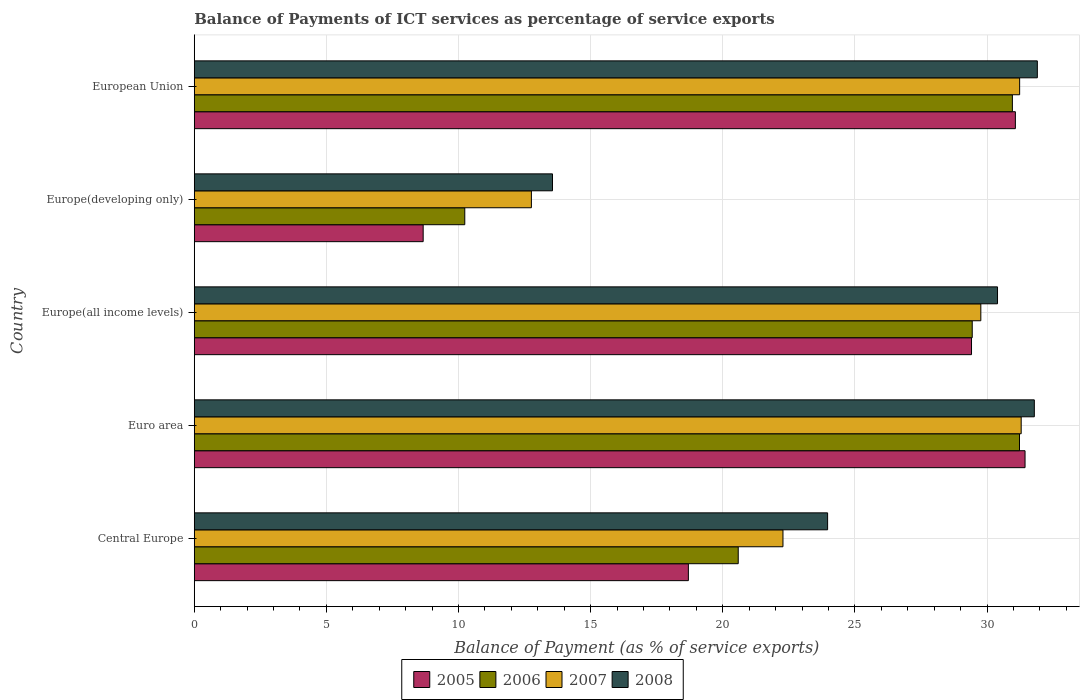How many bars are there on the 2nd tick from the top?
Your answer should be very brief. 4. How many bars are there on the 2nd tick from the bottom?
Provide a short and direct response. 4. What is the balance of payments of ICT services in 2005 in Europe(developing only)?
Provide a succinct answer. 8.66. Across all countries, what is the maximum balance of payments of ICT services in 2008?
Provide a succinct answer. 31.9. Across all countries, what is the minimum balance of payments of ICT services in 2008?
Give a very brief answer. 13.56. In which country was the balance of payments of ICT services in 2005 maximum?
Offer a terse response. Euro area. In which country was the balance of payments of ICT services in 2008 minimum?
Provide a short and direct response. Europe(developing only). What is the total balance of payments of ICT services in 2008 in the graph?
Your answer should be compact. 131.6. What is the difference between the balance of payments of ICT services in 2005 in Central Europe and that in Euro area?
Your answer should be very brief. -12.74. What is the difference between the balance of payments of ICT services in 2008 in Central Europe and the balance of payments of ICT services in 2006 in Europe(all income levels)?
Provide a short and direct response. -5.47. What is the average balance of payments of ICT services in 2006 per country?
Keep it short and to the point. 24.49. What is the difference between the balance of payments of ICT services in 2008 and balance of payments of ICT services in 2005 in Europe(all income levels)?
Provide a succinct answer. 0.98. In how many countries, is the balance of payments of ICT services in 2008 greater than 25 %?
Keep it short and to the point. 3. What is the ratio of the balance of payments of ICT services in 2006 in Euro area to that in Europe(all income levels)?
Offer a terse response. 1.06. Is the balance of payments of ICT services in 2007 in Central Europe less than that in Europe(all income levels)?
Your answer should be very brief. Yes. What is the difference between the highest and the second highest balance of payments of ICT services in 2008?
Your answer should be very brief. 0.11. What is the difference between the highest and the lowest balance of payments of ICT services in 2005?
Provide a succinct answer. 22.77. Is it the case that in every country, the sum of the balance of payments of ICT services in 2005 and balance of payments of ICT services in 2008 is greater than the sum of balance of payments of ICT services in 2006 and balance of payments of ICT services in 2007?
Ensure brevity in your answer.  No. What does the 4th bar from the bottom in Europe(developing only) represents?
Your answer should be very brief. 2008. Is it the case that in every country, the sum of the balance of payments of ICT services in 2007 and balance of payments of ICT services in 2005 is greater than the balance of payments of ICT services in 2008?
Ensure brevity in your answer.  Yes. How many bars are there?
Provide a succinct answer. 20. Are all the bars in the graph horizontal?
Offer a terse response. Yes. How many countries are there in the graph?
Your response must be concise. 5. Are the values on the major ticks of X-axis written in scientific E-notation?
Your response must be concise. No. Where does the legend appear in the graph?
Provide a short and direct response. Bottom center. How many legend labels are there?
Provide a short and direct response. 4. How are the legend labels stacked?
Keep it short and to the point. Horizontal. What is the title of the graph?
Keep it short and to the point. Balance of Payments of ICT services as percentage of service exports. Does "2007" appear as one of the legend labels in the graph?
Provide a short and direct response. Yes. What is the label or title of the X-axis?
Ensure brevity in your answer.  Balance of Payment (as % of service exports). What is the label or title of the Y-axis?
Provide a succinct answer. Country. What is the Balance of Payment (as % of service exports) in 2005 in Central Europe?
Make the answer very short. 18.7. What is the Balance of Payment (as % of service exports) of 2006 in Central Europe?
Keep it short and to the point. 20.58. What is the Balance of Payment (as % of service exports) of 2007 in Central Europe?
Give a very brief answer. 22.28. What is the Balance of Payment (as % of service exports) in 2008 in Central Europe?
Offer a very short reply. 23.97. What is the Balance of Payment (as % of service exports) in 2005 in Euro area?
Make the answer very short. 31.44. What is the Balance of Payment (as % of service exports) of 2006 in Euro area?
Offer a very short reply. 31.23. What is the Balance of Payment (as % of service exports) of 2007 in Euro area?
Offer a very short reply. 31.29. What is the Balance of Payment (as % of service exports) of 2008 in Euro area?
Ensure brevity in your answer.  31.79. What is the Balance of Payment (as % of service exports) in 2005 in Europe(all income levels)?
Keep it short and to the point. 29.41. What is the Balance of Payment (as % of service exports) in 2006 in Europe(all income levels)?
Your answer should be compact. 29.44. What is the Balance of Payment (as % of service exports) of 2007 in Europe(all income levels)?
Keep it short and to the point. 29.76. What is the Balance of Payment (as % of service exports) of 2008 in Europe(all income levels)?
Make the answer very short. 30.39. What is the Balance of Payment (as % of service exports) of 2005 in Europe(developing only)?
Make the answer very short. 8.66. What is the Balance of Payment (as % of service exports) of 2006 in Europe(developing only)?
Provide a succinct answer. 10.24. What is the Balance of Payment (as % of service exports) in 2007 in Europe(developing only)?
Your answer should be very brief. 12.76. What is the Balance of Payment (as % of service exports) in 2008 in Europe(developing only)?
Ensure brevity in your answer.  13.56. What is the Balance of Payment (as % of service exports) of 2005 in European Union?
Your answer should be compact. 31.07. What is the Balance of Payment (as % of service exports) of 2006 in European Union?
Offer a terse response. 30.96. What is the Balance of Payment (as % of service exports) of 2007 in European Union?
Ensure brevity in your answer.  31.23. What is the Balance of Payment (as % of service exports) in 2008 in European Union?
Offer a very short reply. 31.9. Across all countries, what is the maximum Balance of Payment (as % of service exports) of 2005?
Your response must be concise. 31.44. Across all countries, what is the maximum Balance of Payment (as % of service exports) in 2006?
Provide a short and direct response. 31.23. Across all countries, what is the maximum Balance of Payment (as % of service exports) in 2007?
Provide a succinct answer. 31.29. Across all countries, what is the maximum Balance of Payment (as % of service exports) in 2008?
Keep it short and to the point. 31.9. Across all countries, what is the minimum Balance of Payment (as % of service exports) in 2005?
Give a very brief answer. 8.66. Across all countries, what is the minimum Balance of Payment (as % of service exports) in 2006?
Keep it short and to the point. 10.24. Across all countries, what is the minimum Balance of Payment (as % of service exports) of 2007?
Your response must be concise. 12.76. Across all countries, what is the minimum Balance of Payment (as % of service exports) in 2008?
Your response must be concise. 13.56. What is the total Balance of Payment (as % of service exports) of 2005 in the graph?
Provide a short and direct response. 119.27. What is the total Balance of Payment (as % of service exports) of 2006 in the graph?
Provide a succinct answer. 122.44. What is the total Balance of Payment (as % of service exports) of 2007 in the graph?
Your response must be concise. 127.32. What is the total Balance of Payment (as % of service exports) of 2008 in the graph?
Offer a terse response. 131.6. What is the difference between the Balance of Payment (as % of service exports) of 2005 in Central Europe and that in Euro area?
Your response must be concise. -12.74. What is the difference between the Balance of Payment (as % of service exports) in 2006 in Central Europe and that in Euro area?
Offer a terse response. -10.64. What is the difference between the Balance of Payment (as % of service exports) of 2007 in Central Europe and that in Euro area?
Your answer should be compact. -9.01. What is the difference between the Balance of Payment (as % of service exports) in 2008 in Central Europe and that in Euro area?
Offer a very short reply. -7.82. What is the difference between the Balance of Payment (as % of service exports) of 2005 in Central Europe and that in Europe(all income levels)?
Make the answer very short. -10.71. What is the difference between the Balance of Payment (as % of service exports) of 2006 in Central Europe and that in Europe(all income levels)?
Make the answer very short. -8.85. What is the difference between the Balance of Payment (as % of service exports) in 2007 in Central Europe and that in Europe(all income levels)?
Ensure brevity in your answer.  -7.49. What is the difference between the Balance of Payment (as % of service exports) in 2008 in Central Europe and that in Europe(all income levels)?
Provide a succinct answer. -6.43. What is the difference between the Balance of Payment (as % of service exports) of 2005 in Central Europe and that in Europe(developing only)?
Give a very brief answer. 10.04. What is the difference between the Balance of Payment (as % of service exports) of 2006 in Central Europe and that in Europe(developing only)?
Offer a terse response. 10.35. What is the difference between the Balance of Payment (as % of service exports) in 2007 in Central Europe and that in Europe(developing only)?
Offer a very short reply. 9.52. What is the difference between the Balance of Payment (as % of service exports) of 2008 in Central Europe and that in Europe(developing only)?
Ensure brevity in your answer.  10.41. What is the difference between the Balance of Payment (as % of service exports) in 2005 in Central Europe and that in European Union?
Make the answer very short. -12.37. What is the difference between the Balance of Payment (as % of service exports) in 2006 in Central Europe and that in European Union?
Offer a very short reply. -10.37. What is the difference between the Balance of Payment (as % of service exports) of 2007 in Central Europe and that in European Union?
Your response must be concise. -8.96. What is the difference between the Balance of Payment (as % of service exports) of 2008 in Central Europe and that in European Union?
Provide a succinct answer. -7.94. What is the difference between the Balance of Payment (as % of service exports) in 2005 in Euro area and that in Europe(all income levels)?
Ensure brevity in your answer.  2.03. What is the difference between the Balance of Payment (as % of service exports) in 2006 in Euro area and that in Europe(all income levels)?
Keep it short and to the point. 1.79. What is the difference between the Balance of Payment (as % of service exports) of 2007 in Euro area and that in Europe(all income levels)?
Make the answer very short. 1.53. What is the difference between the Balance of Payment (as % of service exports) in 2008 in Euro area and that in Europe(all income levels)?
Make the answer very short. 1.39. What is the difference between the Balance of Payment (as % of service exports) of 2005 in Euro area and that in Europe(developing only)?
Keep it short and to the point. 22.77. What is the difference between the Balance of Payment (as % of service exports) of 2006 in Euro area and that in Europe(developing only)?
Give a very brief answer. 20.99. What is the difference between the Balance of Payment (as % of service exports) in 2007 in Euro area and that in Europe(developing only)?
Ensure brevity in your answer.  18.53. What is the difference between the Balance of Payment (as % of service exports) in 2008 in Euro area and that in Europe(developing only)?
Provide a succinct answer. 18.23. What is the difference between the Balance of Payment (as % of service exports) in 2005 in Euro area and that in European Union?
Your response must be concise. 0.37. What is the difference between the Balance of Payment (as % of service exports) of 2006 in Euro area and that in European Union?
Offer a very short reply. 0.27. What is the difference between the Balance of Payment (as % of service exports) in 2007 in Euro area and that in European Union?
Offer a very short reply. 0.06. What is the difference between the Balance of Payment (as % of service exports) of 2008 in Euro area and that in European Union?
Make the answer very short. -0.11. What is the difference between the Balance of Payment (as % of service exports) of 2005 in Europe(all income levels) and that in Europe(developing only)?
Make the answer very short. 20.75. What is the difference between the Balance of Payment (as % of service exports) of 2006 in Europe(all income levels) and that in Europe(developing only)?
Offer a terse response. 19.2. What is the difference between the Balance of Payment (as % of service exports) in 2007 in Europe(all income levels) and that in Europe(developing only)?
Ensure brevity in your answer.  17.01. What is the difference between the Balance of Payment (as % of service exports) in 2008 in Europe(all income levels) and that in Europe(developing only)?
Your answer should be compact. 16.84. What is the difference between the Balance of Payment (as % of service exports) of 2005 in Europe(all income levels) and that in European Union?
Make the answer very short. -1.66. What is the difference between the Balance of Payment (as % of service exports) in 2006 in Europe(all income levels) and that in European Union?
Keep it short and to the point. -1.52. What is the difference between the Balance of Payment (as % of service exports) of 2007 in Europe(all income levels) and that in European Union?
Provide a succinct answer. -1.47. What is the difference between the Balance of Payment (as % of service exports) of 2008 in Europe(all income levels) and that in European Union?
Provide a short and direct response. -1.51. What is the difference between the Balance of Payment (as % of service exports) in 2005 in Europe(developing only) and that in European Union?
Your answer should be very brief. -22.41. What is the difference between the Balance of Payment (as % of service exports) of 2006 in Europe(developing only) and that in European Union?
Provide a short and direct response. -20.72. What is the difference between the Balance of Payment (as % of service exports) in 2007 in Europe(developing only) and that in European Union?
Offer a terse response. -18.47. What is the difference between the Balance of Payment (as % of service exports) in 2008 in Europe(developing only) and that in European Union?
Make the answer very short. -18.35. What is the difference between the Balance of Payment (as % of service exports) in 2005 in Central Europe and the Balance of Payment (as % of service exports) in 2006 in Euro area?
Your answer should be compact. -12.53. What is the difference between the Balance of Payment (as % of service exports) of 2005 in Central Europe and the Balance of Payment (as % of service exports) of 2007 in Euro area?
Offer a terse response. -12.59. What is the difference between the Balance of Payment (as % of service exports) in 2005 in Central Europe and the Balance of Payment (as % of service exports) in 2008 in Euro area?
Your answer should be compact. -13.09. What is the difference between the Balance of Payment (as % of service exports) in 2006 in Central Europe and the Balance of Payment (as % of service exports) in 2007 in Euro area?
Keep it short and to the point. -10.71. What is the difference between the Balance of Payment (as % of service exports) of 2006 in Central Europe and the Balance of Payment (as % of service exports) of 2008 in Euro area?
Your answer should be very brief. -11.2. What is the difference between the Balance of Payment (as % of service exports) in 2007 in Central Europe and the Balance of Payment (as % of service exports) in 2008 in Euro area?
Provide a short and direct response. -9.51. What is the difference between the Balance of Payment (as % of service exports) in 2005 in Central Europe and the Balance of Payment (as % of service exports) in 2006 in Europe(all income levels)?
Make the answer very short. -10.74. What is the difference between the Balance of Payment (as % of service exports) of 2005 in Central Europe and the Balance of Payment (as % of service exports) of 2007 in Europe(all income levels)?
Your response must be concise. -11.07. What is the difference between the Balance of Payment (as % of service exports) of 2005 in Central Europe and the Balance of Payment (as % of service exports) of 2008 in Europe(all income levels)?
Ensure brevity in your answer.  -11.7. What is the difference between the Balance of Payment (as % of service exports) of 2006 in Central Europe and the Balance of Payment (as % of service exports) of 2007 in Europe(all income levels)?
Provide a short and direct response. -9.18. What is the difference between the Balance of Payment (as % of service exports) in 2006 in Central Europe and the Balance of Payment (as % of service exports) in 2008 in Europe(all income levels)?
Give a very brief answer. -9.81. What is the difference between the Balance of Payment (as % of service exports) of 2007 in Central Europe and the Balance of Payment (as % of service exports) of 2008 in Europe(all income levels)?
Your response must be concise. -8.12. What is the difference between the Balance of Payment (as % of service exports) of 2005 in Central Europe and the Balance of Payment (as % of service exports) of 2006 in Europe(developing only)?
Provide a succinct answer. 8.46. What is the difference between the Balance of Payment (as % of service exports) of 2005 in Central Europe and the Balance of Payment (as % of service exports) of 2007 in Europe(developing only)?
Provide a succinct answer. 5.94. What is the difference between the Balance of Payment (as % of service exports) in 2005 in Central Europe and the Balance of Payment (as % of service exports) in 2008 in Europe(developing only)?
Your answer should be compact. 5.14. What is the difference between the Balance of Payment (as % of service exports) of 2006 in Central Europe and the Balance of Payment (as % of service exports) of 2007 in Europe(developing only)?
Ensure brevity in your answer.  7.83. What is the difference between the Balance of Payment (as % of service exports) of 2006 in Central Europe and the Balance of Payment (as % of service exports) of 2008 in Europe(developing only)?
Provide a short and direct response. 7.03. What is the difference between the Balance of Payment (as % of service exports) of 2007 in Central Europe and the Balance of Payment (as % of service exports) of 2008 in Europe(developing only)?
Make the answer very short. 8.72. What is the difference between the Balance of Payment (as % of service exports) of 2005 in Central Europe and the Balance of Payment (as % of service exports) of 2006 in European Union?
Give a very brief answer. -12.26. What is the difference between the Balance of Payment (as % of service exports) in 2005 in Central Europe and the Balance of Payment (as % of service exports) in 2007 in European Union?
Provide a succinct answer. -12.54. What is the difference between the Balance of Payment (as % of service exports) in 2005 in Central Europe and the Balance of Payment (as % of service exports) in 2008 in European Union?
Your answer should be compact. -13.2. What is the difference between the Balance of Payment (as % of service exports) in 2006 in Central Europe and the Balance of Payment (as % of service exports) in 2007 in European Union?
Make the answer very short. -10.65. What is the difference between the Balance of Payment (as % of service exports) of 2006 in Central Europe and the Balance of Payment (as % of service exports) of 2008 in European Union?
Offer a terse response. -11.32. What is the difference between the Balance of Payment (as % of service exports) of 2007 in Central Europe and the Balance of Payment (as % of service exports) of 2008 in European Union?
Provide a short and direct response. -9.62. What is the difference between the Balance of Payment (as % of service exports) in 2005 in Euro area and the Balance of Payment (as % of service exports) in 2006 in Europe(all income levels)?
Keep it short and to the point. 2. What is the difference between the Balance of Payment (as % of service exports) of 2005 in Euro area and the Balance of Payment (as % of service exports) of 2007 in Europe(all income levels)?
Make the answer very short. 1.67. What is the difference between the Balance of Payment (as % of service exports) in 2005 in Euro area and the Balance of Payment (as % of service exports) in 2008 in Europe(all income levels)?
Give a very brief answer. 1.04. What is the difference between the Balance of Payment (as % of service exports) in 2006 in Euro area and the Balance of Payment (as % of service exports) in 2007 in Europe(all income levels)?
Your answer should be compact. 1.46. What is the difference between the Balance of Payment (as % of service exports) in 2006 in Euro area and the Balance of Payment (as % of service exports) in 2008 in Europe(all income levels)?
Provide a succinct answer. 0.83. What is the difference between the Balance of Payment (as % of service exports) of 2007 in Euro area and the Balance of Payment (as % of service exports) of 2008 in Europe(all income levels)?
Keep it short and to the point. 0.9. What is the difference between the Balance of Payment (as % of service exports) in 2005 in Euro area and the Balance of Payment (as % of service exports) in 2006 in Europe(developing only)?
Offer a terse response. 21.2. What is the difference between the Balance of Payment (as % of service exports) of 2005 in Euro area and the Balance of Payment (as % of service exports) of 2007 in Europe(developing only)?
Offer a terse response. 18.68. What is the difference between the Balance of Payment (as % of service exports) of 2005 in Euro area and the Balance of Payment (as % of service exports) of 2008 in Europe(developing only)?
Your answer should be very brief. 17.88. What is the difference between the Balance of Payment (as % of service exports) of 2006 in Euro area and the Balance of Payment (as % of service exports) of 2007 in Europe(developing only)?
Offer a terse response. 18.47. What is the difference between the Balance of Payment (as % of service exports) of 2006 in Euro area and the Balance of Payment (as % of service exports) of 2008 in Europe(developing only)?
Your answer should be compact. 17.67. What is the difference between the Balance of Payment (as % of service exports) of 2007 in Euro area and the Balance of Payment (as % of service exports) of 2008 in Europe(developing only)?
Make the answer very short. 17.73. What is the difference between the Balance of Payment (as % of service exports) of 2005 in Euro area and the Balance of Payment (as % of service exports) of 2006 in European Union?
Offer a terse response. 0.48. What is the difference between the Balance of Payment (as % of service exports) of 2005 in Euro area and the Balance of Payment (as % of service exports) of 2007 in European Union?
Offer a very short reply. 0.2. What is the difference between the Balance of Payment (as % of service exports) of 2005 in Euro area and the Balance of Payment (as % of service exports) of 2008 in European Union?
Give a very brief answer. -0.47. What is the difference between the Balance of Payment (as % of service exports) of 2006 in Euro area and the Balance of Payment (as % of service exports) of 2007 in European Union?
Offer a very short reply. -0.01. What is the difference between the Balance of Payment (as % of service exports) of 2006 in Euro area and the Balance of Payment (as % of service exports) of 2008 in European Union?
Give a very brief answer. -0.68. What is the difference between the Balance of Payment (as % of service exports) in 2007 in Euro area and the Balance of Payment (as % of service exports) in 2008 in European Union?
Ensure brevity in your answer.  -0.61. What is the difference between the Balance of Payment (as % of service exports) of 2005 in Europe(all income levels) and the Balance of Payment (as % of service exports) of 2006 in Europe(developing only)?
Offer a terse response. 19.17. What is the difference between the Balance of Payment (as % of service exports) in 2005 in Europe(all income levels) and the Balance of Payment (as % of service exports) in 2007 in Europe(developing only)?
Give a very brief answer. 16.65. What is the difference between the Balance of Payment (as % of service exports) in 2005 in Europe(all income levels) and the Balance of Payment (as % of service exports) in 2008 in Europe(developing only)?
Your answer should be compact. 15.86. What is the difference between the Balance of Payment (as % of service exports) of 2006 in Europe(all income levels) and the Balance of Payment (as % of service exports) of 2007 in Europe(developing only)?
Offer a very short reply. 16.68. What is the difference between the Balance of Payment (as % of service exports) in 2006 in Europe(all income levels) and the Balance of Payment (as % of service exports) in 2008 in Europe(developing only)?
Provide a short and direct response. 15.88. What is the difference between the Balance of Payment (as % of service exports) of 2007 in Europe(all income levels) and the Balance of Payment (as % of service exports) of 2008 in Europe(developing only)?
Your answer should be very brief. 16.21. What is the difference between the Balance of Payment (as % of service exports) in 2005 in Europe(all income levels) and the Balance of Payment (as % of service exports) in 2006 in European Union?
Your answer should be very brief. -1.55. What is the difference between the Balance of Payment (as % of service exports) of 2005 in Europe(all income levels) and the Balance of Payment (as % of service exports) of 2007 in European Union?
Make the answer very short. -1.82. What is the difference between the Balance of Payment (as % of service exports) of 2005 in Europe(all income levels) and the Balance of Payment (as % of service exports) of 2008 in European Union?
Your answer should be compact. -2.49. What is the difference between the Balance of Payment (as % of service exports) of 2006 in Europe(all income levels) and the Balance of Payment (as % of service exports) of 2007 in European Union?
Offer a very short reply. -1.79. What is the difference between the Balance of Payment (as % of service exports) in 2006 in Europe(all income levels) and the Balance of Payment (as % of service exports) in 2008 in European Union?
Ensure brevity in your answer.  -2.46. What is the difference between the Balance of Payment (as % of service exports) of 2007 in Europe(all income levels) and the Balance of Payment (as % of service exports) of 2008 in European Union?
Make the answer very short. -2.14. What is the difference between the Balance of Payment (as % of service exports) of 2005 in Europe(developing only) and the Balance of Payment (as % of service exports) of 2006 in European Union?
Offer a very short reply. -22.3. What is the difference between the Balance of Payment (as % of service exports) of 2005 in Europe(developing only) and the Balance of Payment (as % of service exports) of 2007 in European Union?
Your response must be concise. -22.57. What is the difference between the Balance of Payment (as % of service exports) of 2005 in Europe(developing only) and the Balance of Payment (as % of service exports) of 2008 in European Union?
Offer a terse response. -23.24. What is the difference between the Balance of Payment (as % of service exports) in 2006 in Europe(developing only) and the Balance of Payment (as % of service exports) in 2007 in European Union?
Offer a terse response. -21. What is the difference between the Balance of Payment (as % of service exports) of 2006 in Europe(developing only) and the Balance of Payment (as % of service exports) of 2008 in European Union?
Your response must be concise. -21.66. What is the difference between the Balance of Payment (as % of service exports) in 2007 in Europe(developing only) and the Balance of Payment (as % of service exports) in 2008 in European Union?
Provide a succinct answer. -19.14. What is the average Balance of Payment (as % of service exports) in 2005 per country?
Make the answer very short. 23.85. What is the average Balance of Payment (as % of service exports) in 2006 per country?
Ensure brevity in your answer.  24.49. What is the average Balance of Payment (as % of service exports) of 2007 per country?
Keep it short and to the point. 25.46. What is the average Balance of Payment (as % of service exports) of 2008 per country?
Provide a succinct answer. 26.32. What is the difference between the Balance of Payment (as % of service exports) in 2005 and Balance of Payment (as % of service exports) in 2006 in Central Europe?
Your answer should be compact. -1.89. What is the difference between the Balance of Payment (as % of service exports) in 2005 and Balance of Payment (as % of service exports) in 2007 in Central Europe?
Your answer should be very brief. -3.58. What is the difference between the Balance of Payment (as % of service exports) in 2005 and Balance of Payment (as % of service exports) in 2008 in Central Europe?
Provide a succinct answer. -5.27. What is the difference between the Balance of Payment (as % of service exports) of 2006 and Balance of Payment (as % of service exports) of 2007 in Central Europe?
Provide a succinct answer. -1.69. What is the difference between the Balance of Payment (as % of service exports) in 2006 and Balance of Payment (as % of service exports) in 2008 in Central Europe?
Ensure brevity in your answer.  -3.38. What is the difference between the Balance of Payment (as % of service exports) in 2007 and Balance of Payment (as % of service exports) in 2008 in Central Europe?
Provide a succinct answer. -1.69. What is the difference between the Balance of Payment (as % of service exports) in 2005 and Balance of Payment (as % of service exports) in 2006 in Euro area?
Provide a succinct answer. 0.21. What is the difference between the Balance of Payment (as % of service exports) in 2005 and Balance of Payment (as % of service exports) in 2007 in Euro area?
Provide a short and direct response. 0.15. What is the difference between the Balance of Payment (as % of service exports) of 2005 and Balance of Payment (as % of service exports) of 2008 in Euro area?
Provide a succinct answer. -0.35. What is the difference between the Balance of Payment (as % of service exports) of 2006 and Balance of Payment (as % of service exports) of 2007 in Euro area?
Provide a short and direct response. -0.06. What is the difference between the Balance of Payment (as % of service exports) of 2006 and Balance of Payment (as % of service exports) of 2008 in Euro area?
Your answer should be compact. -0.56. What is the difference between the Balance of Payment (as % of service exports) of 2007 and Balance of Payment (as % of service exports) of 2008 in Euro area?
Ensure brevity in your answer.  -0.5. What is the difference between the Balance of Payment (as % of service exports) of 2005 and Balance of Payment (as % of service exports) of 2006 in Europe(all income levels)?
Offer a very short reply. -0.03. What is the difference between the Balance of Payment (as % of service exports) in 2005 and Balance of Payment (as % of service exports) in 2007 in Europe(all income levels)?
Offer a terse response. -0.35. What is the difference between the Balance of Payment (as % of service exports) of 2005 and Balance of Payment (as % of service exports) of 2008 in Europe(all income levels)?
Provide a short and direct response. -0.98. What is the difference between the Balance of Payment (as % of service exports) in 2006 and Balance of Payment (as % of service exports) in 2007 in Europe(all income levels)?
Make the answer very short. -0.33. What is the difference between the Balance of Payment (as % of service exports) of 2006 and Balance of Payment (as % of service exports) of 2008 in Europe(all income levels)?
Make the answer very short. -0.96. What is the difference between the Balance of Payment (as % of service exports) in 2007 and Balance of Payment (as % of service exports) in 2008 in Europe(all income levels)?
Offer a very short reply. -0.63. What is the difference between the Balance of Payment (as % of service exports) of 2005 and Balance of Payment (as % of service exports) of 2006 in Europe(developing only)?
Offer a very short reply. -1.57. What is the difference between the Balance of Payment (as % of service exports) of 2005 and Balance of Payment (as % of service exports) of 2007 in Europe(developing only)?
Make the answer very short. -4.1. What is the difference between the Balance of Payment (as % of service exports) of 2005 and Balance of Payment (as % of service exports) of 2008 in Europe(developing only)?
Offer a terse response. -4.89. What is the difference between the Balance of Payment (as % of service exports) in 2006 and Balance of Payment (as % of service exports) in 2007 in Europe(developing only)?
Make the answer very short. -2.52. What is the difference between the Balance of Payment (as % of service exports) in 2006 and Balance of Payment (as % of service exports) in 2008 in Europe(developing only)?
Provide a short and direct response. -3.32. What is the difference between the Balance of Payment (as % of service exports) of 2007 and Balance of Payment (as % of service exports) of 2008 in Europe(developing only)?
Offer a terse response. -0.8. What is the difference between the Balance of Payment (as % of service exports) in 2005 and Balance of Payment (as % of service exports) in 2006 in European Union?
Make the answer very short. 0.11. What is the difference between the Balance of Payment (as % of service exports) of 2005 and Balance of Payment (as % of service exports) of 2007 in European Union?
Give a very brief answer. -0.16. What is the difference between the Balance of Payment (as % of service exports) in 2005 and Balance of Payment (as % of service exports) in 2008 in European Union?
Give a very brief answer. -0.83. What is the difference between the Balance of Payment (as % of service exports) in 2006 and Balance of Payment (as % of service exports) in 2007 in European Union?
Your answer should be compact. -0.27. What is the difference between the Balance of Payment (as % of service exports) in 2006 and Balance of Payment (as % of service exports) in 2008 in European Union?
Give a very brief answer. -0.94. What is the difference between the Balance of Payment (as % of service exports) of 2007 and Balance of Payment (as % of service exports) of 2008 in European Union?
Your answer should be compact. -0.67. What is the ratio of the Balance of Payment (as % of service exports) of 2005 in Central Europe to that in Euro area?
Make the answer very short. 0.59. What is the ratio of the Balance of Payment (as % of service exports) of 2006 in Central Europe to that in Euro area?
Provide a short and direct response. 0.66. What is the ratio of the Balance of Payment (as % of service exports) of 2007 in Central Europe to that in Euro area?
Ensure brevity in your answer.  0.71. What is the ratio of the Balance of Payment (as % of service exports) of 2008 in Central Europe to that in Euro area?
Keep it short and to the point. 0.75. What is the ratio of the Balance of Payment (as % of service exports) of 2005 in Central Europe to that in Europe(all income levels)?
Give a very brief answer. 0.64. What is the ratio of the Balance of Payment (as % of service exports) of 2006 in Central Europe to that in Europe(all income levels)?
Your response must be concise. 0.7. What is the ratio of the Balance of Payment (as % of service exports) of 2007 in Central Europe to that in Europe(all income levels)?
Your response must be concise. 0.75. What is the ratio of the Balance of Payment (as % of service exports) in 2008 in Central Europe to that in Europe(all income levels)?
Provide a short and direct response. 0.79. What is the ratio of the Balance of Payment (as % of service exports) in 2005 in Central Europe to that in Europe(developing only)?
Ensure brevity in your answer.  2.16. What is the ratio of the Balance of Payment (as % of service exports) of 2006 in Central Europe to that in Europe(developing only)?
Make the answer very short. 2.01. What is the ratio of the Balance of Payment (as % of service exports) in 2007 in Central Europe to that in Europe(developing only)?
Ensure brevity in your answer.  1.75. What is the ratio of the Balance of Payment (as % of service exports) in 2008 in Central Europe to that in Europe(developing only)?
Your response must be concise. 1.77. What is the ratio of the Balance of Payment (as % of service exports) in 2005 in Central Europe to that in European Union?
Your answer should be very brief. 0.6. What is the ratio of the Balance of Payment (as % of service exports) in 2006 in Central Europe to that in European Union?
Ensure brevity in your answer.  0.66. What is the ratio of the Balance of Payment (as % of service exports) of 2007 in Central Europe to that in European Union?
Provide a succinct answer. 0.71. What is the ratio of the Balance of Payment (as % of service exports) of 2008 in Central Europe to that in European Union?
Keep it short and to the point. 0.75. What is the ratio of the Balance of Payment (as % of service exports) of 2005 in Euro area to that in Europe(all income levels)?
Provide a short and direct response. 1.07. What is the ratio of the Balance of Payment (as % of service exports) of 2006 in Euro area to that in Europe(all income levels)?
Offer a terse response. 1.06. What is the ratio of the Balance of Payment (as % of service exports) in 2007 in Euro area to that in Europe(all income levels)?
Offer a very short reply. 1.05. What is the ratio of the Balance of Payment (as % of service exports) in 2008 in Euro area to that in Europe(all income levels)?
Provide a succinct answer. 1.05. What is the ratio of the Balance of Payment (as % of service exports) of 2005 in Euro area to that in Europe(developing only)?
Provide a short and direct response. 3.63. What is the ratio of the Balance of Payment (as % of service exports) of 2006 in Euro area to that in Europe(developing only)?
Give a very brief answer. 3.05. What is the ratio of the Balance of Payment (as % of service exports) in 2007 in Euro area to that in Europe(developing only)?
Offer a very short reply. 2.45. What is the ratio of the Balance of Payment (as % of service exports) of 2008 in Euro area to that in Europe(developing only)?
Provide a short and direct response. 2.35. What is the ratio of the Balance of Payment (as % of service exports) of 2005 in Euro area to that in European Union?
Give a very brief answer. 1.01. What is the ratio of the Balance of Payment (as % of service exports) of 2006 in Euro area to that in European Union?
Your answer should be very brief. 1.01. What is the ratio of the Balance of Payment (as % of service exports) in 2007 in Euro area to that in European Union?
Give a very brief answer. 1. What is the ratio of the Balance of Payment (as % of service exports) in 2005 in Europe(all income levels) to that in Europe(developing only)?
Provide a short and direct response. 3.4. What is the ratio of the Balance of Payment (as % of service exports) in 2006 in Europe(all income levels) to that in Europe(developing only)?
Offer a very short reply. 2.88. What is the ratio of the Balance of Payment (as % of service exports) of 2007 in Europe(all income levels) to that in Europe(developing only)?
Your answer should be compact. 2.33. What is the ratio of the Balance of Payment (as % of service exports) of 2008 in Europe(all income levels) to that in Europe(developing only)?
Your response must be concise. 2.24. What is the ratio of the Balance of Payment (as % of service exports) of 2005 in Europe(all income levels) to that in European Union?
Provide a short and direct response. 0.95. What is the ratio of the Balance of Payment (as % of service exports) in 2006 in Europe(all income levels) to that in European Union?
Provide a succinct answer. 0.95. What is the ratio of the Balance of Payment (as % of service exports) in 2007 in Europe(all income levels) to that in European Union?
Your answer should be compact. 0.95. What is the ratio of the Balance of Payment (as % of service exports) in 2008 in Europe(all income levels) to that in European Union?
Keep it short and to the point. 0.95. What is the ratio of the Balance of Payment (as % of service exports) in 2005 in Europe(developing only) to that in European Union?
Provide a succinct answer. 0.28. What is the ratio of the Balance of Payment (as % of service exports) in 2006 in Europe(developing only) to that in European Union?
Offer a terse response. 0.33. What is the ratio of the Balance of Payment (as % of service exports) in 2007 in Europe(developing only) to that in European Union?
Keep it short and to the point. 0.41. What is the ratio of the Balance of Payment (as % of service exports) in 2008 in Europe(developing only) to that in European Union?
Ensure brevity in your answer.  0.42. What is the difference between the highest and the second highest Balance of Payment (as % of service exports) of 2005?
Offer a very short reply. 0.37. What is the difference between the highest and the second highest Balance of Payment (as % of service exports) of 2006?
Your answer should be compact. 0.27. What is the difference between the highest and the second highest Balance of Payment (as % of service exports) of 2007?
Provide a short and direct response. 0.06. What is the difference between the highest and the second highest Balance of Payment (as % of service exports) in 2008?
Give a very brief answer. 0.11. What is the difference between the highest and the lowest Balance of Payment (as % of service exports) in 2005?
Provide a succinct answer. 22.77. What is the difference between the highest and the lowest Balance of Payment (as % of service exports) in 2006?
Offer a terse response. 20.99. What is the difference between the highest and the lowest Balance of Payment (as % of service exports) in 2007?
Make the answer very short. 18.53. What is the difference between the highest and the lowest Balance of Payment (as % of service exports) in 2008?
Give a very brief answer. 18.35. 